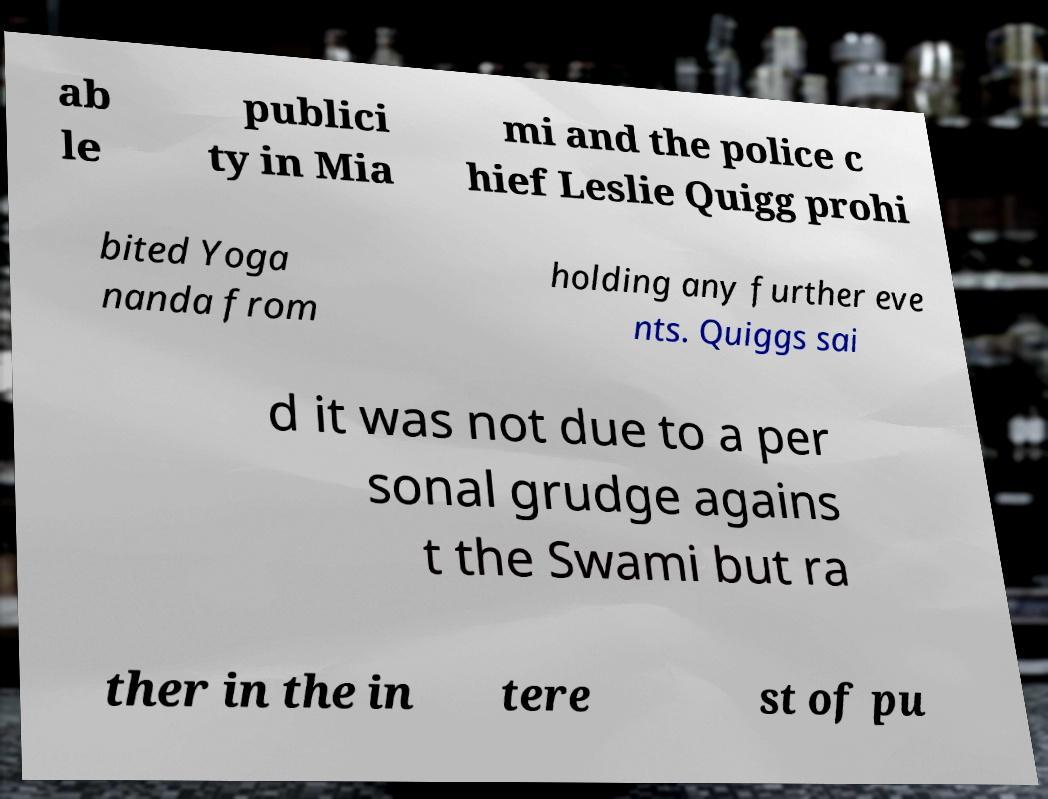Could you extract and type out the text from this image? ab le publici ty in Mia mi and the police c hief Leslie Quigg prohi bited Yoga nanda from holding any further eve nts. Quiggs sai d it was not due to a per sonal grudge agains t the Swami but ra ther in the in tere st of pu 